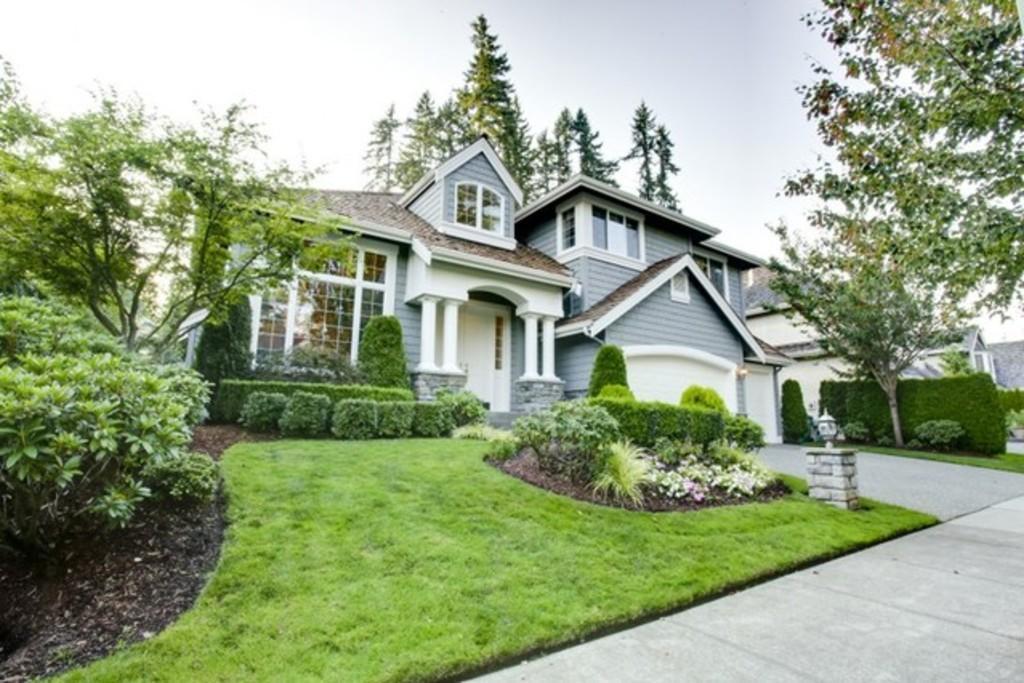Could you give a brief overview of what you see in this image? In the image we can see there are houses and there are windows of the house. Here we can see footpath, grass, plants, trees and the sky. 